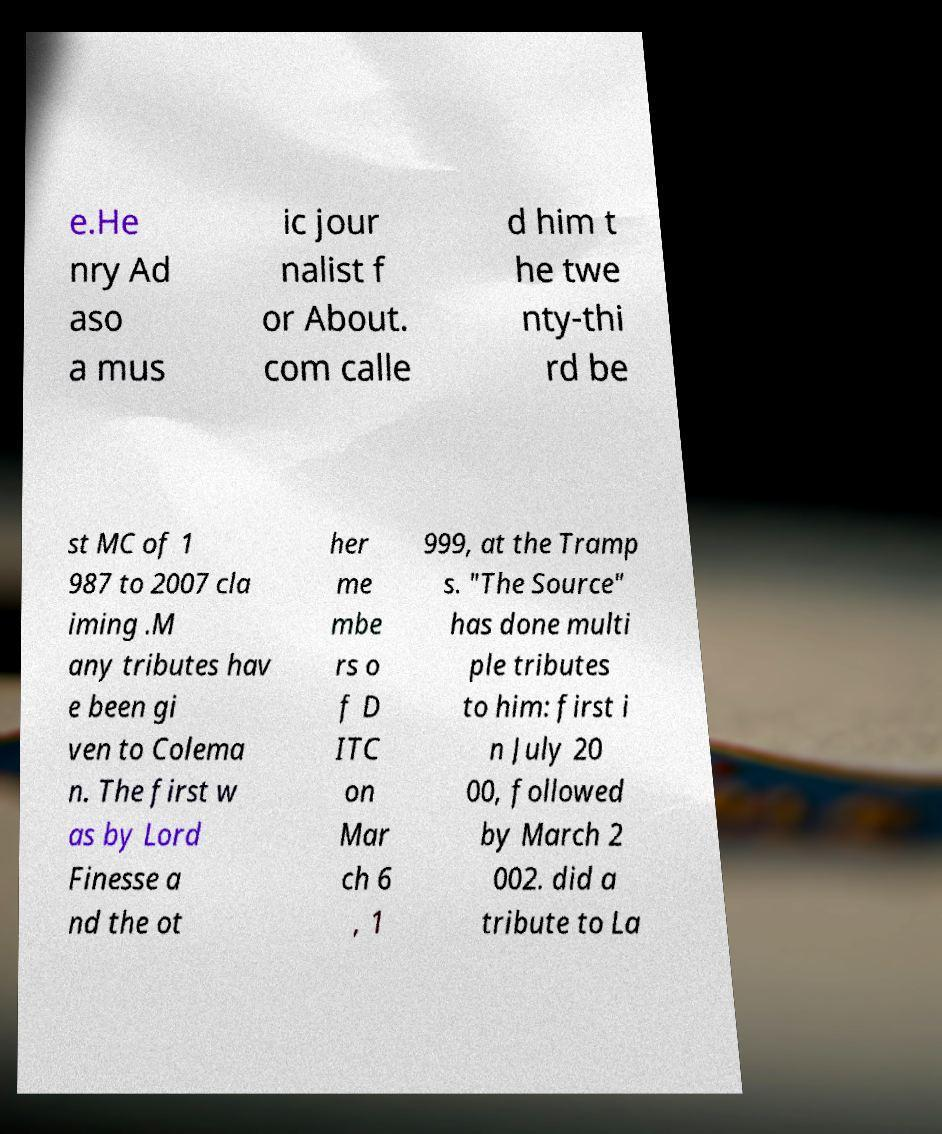For documentation purposes, I need the text within this image transcribed. Could you provide that? e.He nry Ad aso a mus ic jour nalist f or About. com calle d him t he twe nty-thi rd be st MC of 1 987 to 2007 cla iming .M any tributes hav e been gi ven to Colema n. The first w as by Lord Finesse a nd the ot her me mbe rs o f D ITC on Mar ch 6 , 1 999, at the Tramp s. "The Source" has done multi ple tributes to him: first i n July 20 00, followed by March 2 002. did a tribute to La 